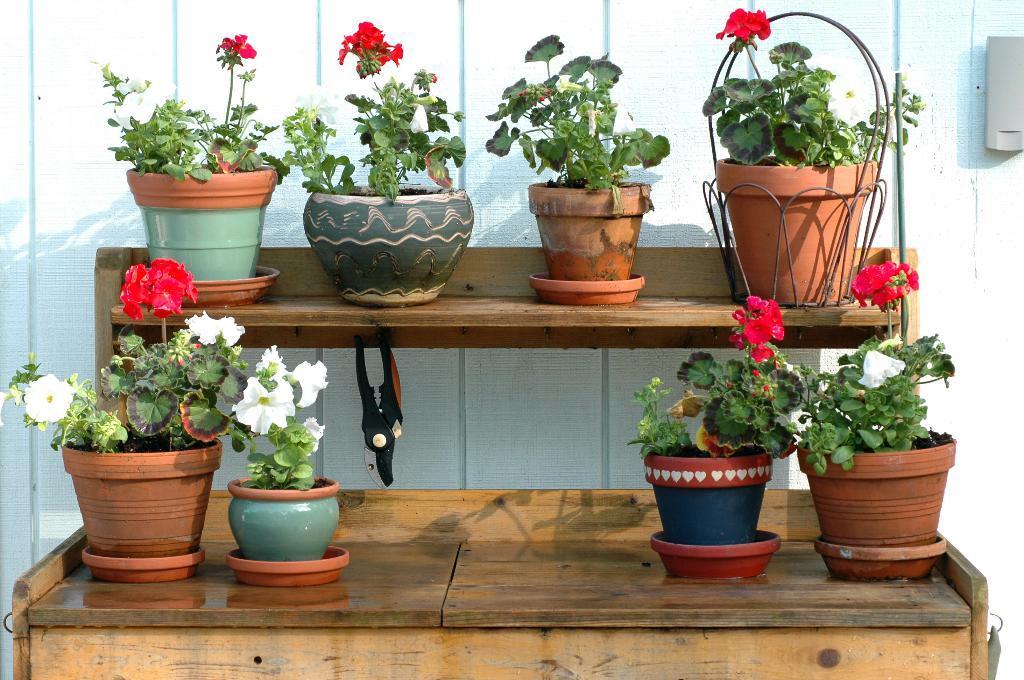How would you summarize this image in a sentence or two? In the foreground I can see house plants which are kept on the tables. In the background I can see a wall. This image is taken during a day outside the house. 